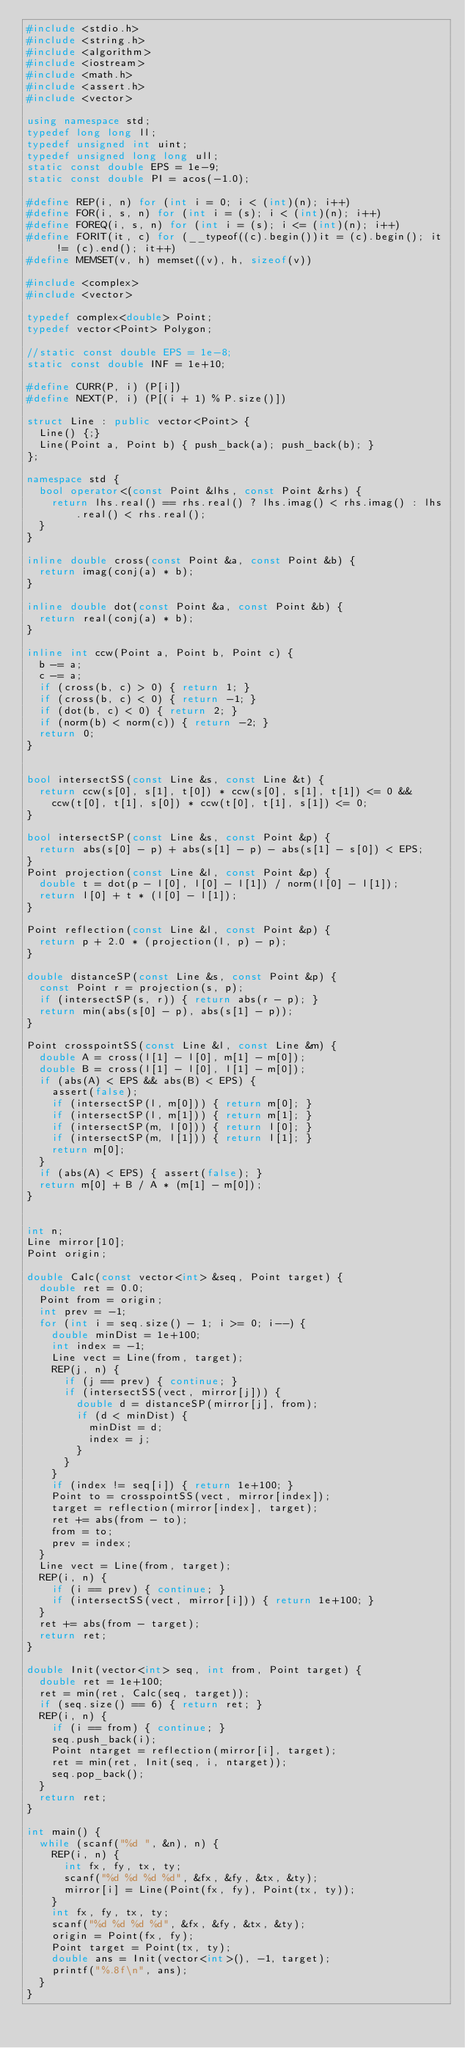<code> <loc_0><loc_0><loc_500><loc_500><_C++_>#include <stdio.h>
#include <string.h>
#include <algorithm>
#include <iostream>
#include <math.h>
#include <assert.h>
#include <vector>

using namespace std;
typedef long long ll;
typedef unsigned int uint;
typedef unsigned long long ull;
static const double EPS = 1e-9;
static const double PI = acos(-1.0);

#define REP(i, n) for (int i = 0; i < (int)(n); i++)
#define FOR(i, s, n) for (int i = (s); i < (int)(n); i++)
#define FOREQ(i, s, n) for (int i = (s); i <= (int)(n); i++)
#define FORIT(it, c) for (__typeof((c).begin())it = (c).begin(); it != (c).end(); it++)
#define MEMSET(v, h) memset((v), h, sizeof(v))

#include <complex>
#include <vector>

typedef complex<double> Point;
typedef vector<Point> Polygon;

//static const double EPS = 1e-8;
static const double INF = 1e+10;

#define CURR(P, i) (P[i])
#define NEXT(P, i) (P[(i + 1) % P.size()])

struct Line : public vector<Point> {
  Line() {;}
  Line(Point a, Point b) { push_back(a); push_back(b); }
};

namespace std {
  bool operator<(const Point &lhs, const Point &rhs) {
    return lhs.real() == rhs.real() ? lhs.imag() < rhs.imag() : lhs.real() < rhs.real();
  }
}

inline double cross(const Point &a, const Point &b) {
  return imag(conj(a) * b);
}

inline double dot(const Point &a, const Point &b) {
  return real(conj(a) * b);
}

inline int ccw(Point a, Point b, Point c) {
  b -= a;
  c -= a;
  if (cross(b, c) > 0) { return 1; }
  if (cross(b, c) < 0) { return -1; }
  if (dot(b, c) < 0) { return 2; }
  if (norm(b) < norm(c)) { return -2; }
  return 0;
}


bool intersectSS(const Line &s, const Line &t) {
  return ccw(s[0], s[1], t[0]) * ccw(s[0], s[1], t[1]) <= 0 &&
    ccw(t[0], t[1], s[0]) * ccw(t[0], t[1], s[1]) <= 0;
}

bool intersectSP(const Line &s, const Point &p) {
  return abs(s[0] - p) + abs(s[1] - p) - abs(s[1] - s[0]) < EPS;
}
Point projection(const Line &l, const Point &p) {
  double t = dot(p - l[0], l[0] - l[1]) / norm(l[0] - l[1]);
  return l[0] + t * (l[0] - l[1]);
}

Point reflection(const Line &l, const Point &p) {
  return p + 2.0 * (projection(l, p) - p);
}

double distanceSP(const Line &s, const Point &p) {
  const Point r = projection(s, p);
  if (intersectSP(s, r)) { return abs(r - p); }
  return min(abs(s[0] - p), abs(s[1] - p));
}

Point crosspointSS(const Line &l, const Line &m) {
  double A = cross(l[1] - l[0], m[1] - m[0]);
  double B = cross(l[1] - l[0], l[1] - m[0]);
  if (abs(A) < EPS && abs(B) < EPS) {
    assert(false);
    if (intersectSP(l, m[0])) { return m[0]; }
    if (intersectSP(l, m[1])) { return m[1]; }
    if (intersectSP(m, l[0])) { return l[0]; }
    if (intersectSP(m, l[1])) { return l[1]; }
    return m[0];
  }
  if (abs(A) < EPS) { assert(false); }
  return m[0] + B / A * (m[1] - m[0]);
}


int n;
Line mirror[10];
Point origin;

double Calc(const vector<int> &seq, Point target) {
  double ret = 0.0;
  Point from = origin;
  int prev = -1;
  for (int i = seq.size() - 1; i >= 0; i--) {
    double minDist = 1e+100;
    int index = -1;
    Line vect = Line(from, target);
    REP(j, n) {
      if (j == prev) { continue; }
      if (intersectSS(vect, mirror[j])) {
        double d = distanceSP(mirror[j], from);
        if (d < minDist) {
          minDist = d;
          index = j;
        }
      }
    }
    if (index != seq[i]) { return 1e+100; }
    Point to = crosspointSS(vect, mirror[index]);
    target = reflection(mirror[index], target);
    ret += abs(from - to);
    from = to;
    prev = index;
  }
  Line vect = Line(from, target);
  REP(i, n) {
    if (i == prev) { continue; }
    if (intersectSS(vect, mirror[i])) { return 1e+100; }
  }
  ret += abs(from - target);
  return ret;
}

double Init(vector<int> seq, int from, Point target) {
  double ret = 1e+100;
  ret = min(ret, Calc(seq, target));
  if (seq.size() == 6) { return ret; }
  REP(i, n) {
    if (i == from) { continue; }
    seq.push_back(i);
    Point ntarget = reflection(mirror[i], target);
    ret = min(ret, Init(seq, i, ntarget));
    seq.pop_back();
  }
  return ret;
}

int main() {
  while (scanf("%d ", &n), n) {
    REP(i, n) {
      int fx, fy, tx, ty;
      scanf("%d %d %d %d", &fx, &fy, &tx, &ty);
      mirror[i] = Line(Point(fx, fy), Point(tx, ty));
    }
    int fx, fy, tx, ty;
    scanf("%d %d %d %d", &fx, &fy, &tx, &ty);
    origin = Point(fx, fy);
    Point target = Point(tx, ty);
    double ans = Init(vector<int>(), -1, target);
    printf("%.8f\n", ans);
  }
}</code> 